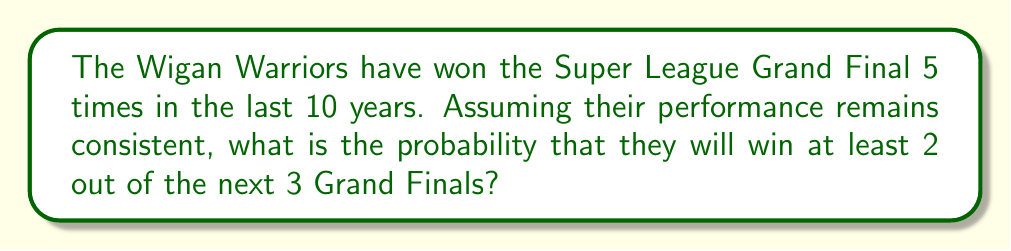Teach me how to tackle this problem. To solve this problem, we'll use the binomial probability distribution and the concept of complementary events.

1. First, let's define our probability of success:
   $p = \frac{5}{10} = 0.5$ (Wigan's win rate over the last 10 years)

2. We want the probability of winning at least 2 out of 3 finals. This is equivalent to the probability of winning 2 or 3 finals.

3. Let's calculate the probability of each scenario:

   a) Probability of winning exactly 2 out of 3:
      $P(X=2) = \binom{3}{2} \cdot 0.5^2 \cdot (1-0.5)^1$
      $= 3 \cdot 0.25 \cdot 0.5 = 0.375$

   b) Probability of winning all 3:
      $P(X=3) = \binom{3}{3} \cdot 0.5^3$
      $= 1 \cdot 0.125 = 0.125$

4. The probability of winning at least 2 out of 3 is the sum of these probabilities:

   $P(X \geq 2) = P(X=2) + P(X=3) = 0.375 + 0.125 = 0.5$

Alternatively, we could have used the complement method:

5. Probability of winning less than 2 (i.e., 0 or 1) is:

   $P(X < 2) = P(X=0) + P(X=1)$
   $= \binom{3}{0} \cdot 0.5^0 \cdot 0.5^3 + \binom{3}{1} \cdot 0.5^1 \cdot 0.5^2$
   $= 0.125 + 0.375 = 0.5$

6. Therefore, $P(X \geq 2) = 1 - P(X < 2) = 1 - 0.5 = 0.5$

Both methods yield the same result.
Answer: The probability that the Wigan Warriors will win at least 2 out of the next 3 Super League Grand Finals is 0.5 or 50%. 